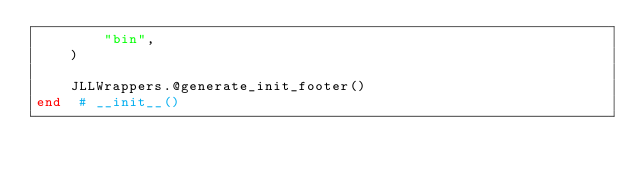<code> <loc_0><loc_0><loc_500><loc_500><_Julia_>        "bin",
    )

    JLLWrappers.@generate_init_footer()
end  # __init__()
</code> 